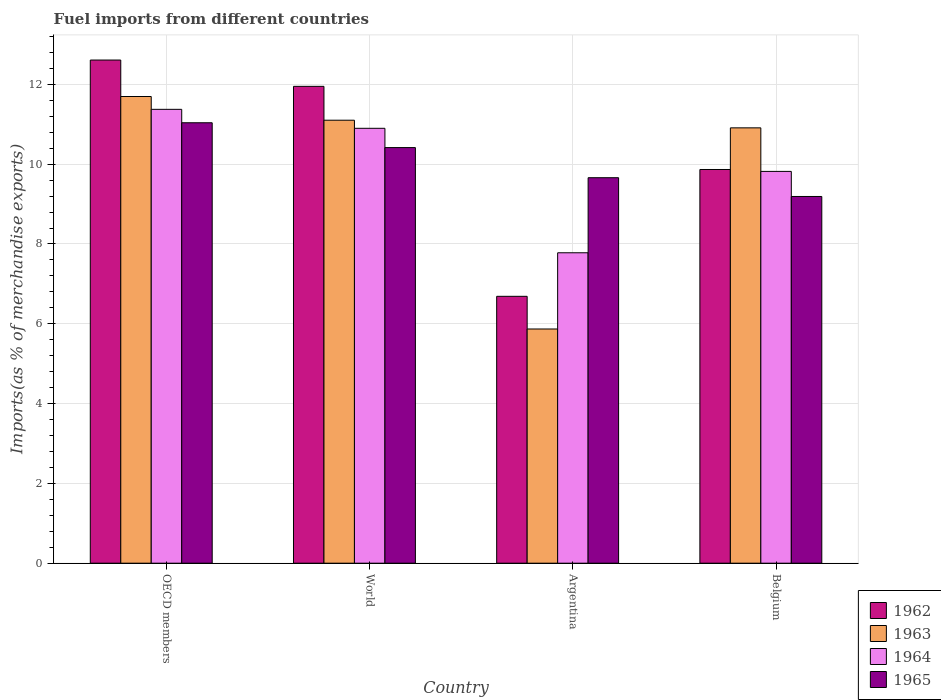How many groups of bars are there?
Your answer should be very brief. 4. Are the number of bars per tick equal to the number of legend labels?
Keep it short and to the point. Yes. Are the number of bars on each tick of the X-axis equal?
Offer a terse response. Yes. How many bars are there on the 4th tick from the right?
Your answer should be very brief. 4. What is the label of the 1st group of bars from the left?
Make the answer very short. OECD members. In how many cases, is the number of bars for a given country not equal to the number of legend labels?
Ensure brevity in your answer.  0. What is the percentage of imports to different countries in 1962 in OECD members?
Your answer should be very brief. 12.61. Across all countries, what is the maximum percentage of imports to different countries in 1963?
Provide a succinct answer. 11.7. Across all countries, what is the minimum percentage of imports to different countries in 1964?
Make the answer very short. 7.78. In which country was the percentage of imports to different countries in 1964 minimum?
Your answer should be very brief. Argentina. What is the total percentage of imports to different countries in 1963 in the graph?
Offer a very short reply. 39.58. What is the difference between the percentage of imports to different countries in 1965 in Argentina and that in World?
Provide a short and direct response. -0.75. What is the difference between the percentage of imports to different countries in 1963 in OECD members and the percentage of imports to different countries in 1965 in Belgium?
Offer a terse response. 2.51. What is the average percentage of imports to different countries in 1963 per country?
Ensure brevity in your answer.  9.89. What is the difference between the percentage of imports to different countries of/in 1965 and percentage of imports to different countries of/in 1964 in Argentina?
Provide a succinct answer. 1.88. In how many countries, is the percentage of imports to different countries in 1963 greater than 8 %?
Keep it short and to the point. 3. What is the ratio of the percentage of imports to different countries in 1964 in Argentina to that in OECD members?
Make the answer very short. 0.68. Is the difference between the percentage of imports to different countries in 1965 in Argentina and World greater than the difference between the percentage of imports to different countries in 1964 in Argentina and World?
Provide a succinct answer. Yes. What is the difference between the highest and the second highest percentage of imports to different countries in 1964?
Offer a very short reply. -1.08. What is the difference between the highest and the lowest percentage of imports to different countries in 1964?
Keep it short and to the point. 3.59. In how many countries, is the percentage of imports to different countries in 1965 greater than the average percentage of imports to different countries in 1965 taken over all countries?
Offer a very short reply. 2. Is the sum of the percentage of imports to different countries in 1963 in OECD members and World greater than the maximum percentage of imports to different countries in 1965 across all countries?
Keep it short and to the point. Yes. What does the 2nd bar from the right in OECD members represents?
Provide a succinct answer. 1964. Are all the bars in the graph horizontal?
Ensure brevity in your answer.  No. What is the difference between two consecutive major ticks on the Y-axis?
Your answer should be very brief. 2. Does the graph contain any zero values?
Your answer should be compact. No. Does the graph contain grids?
Ensure brevity in your answer.  Yes. What is the title of the graph?
Provide a succinct answer. Fuel imports from different countries. What is the label or title of the X-axis?
Your response must be concise. Country. What is the label or title of the Y-axis?
Provide a succinct answer. Imports(as % of merchandise exports). What is the Imports(as % of merchandise exports) of 1962 in OECD members?
Your answer should be compact. 12.61. What is the Imports(as % of merchandise exports) of 1963 in OECD members?
Give a very brief answer. 11.7. What is the Imports(as % of merchandise exports) in 1964 in OECD members?
Keep it short and to the point. 11.37. What is the Imports(as % of merchandise exports) of 1965 in OECD members?
Provide a succinct answer. 11.04. What is the Imports(as % of merchandise exports) of 1962 in World?
Offer a very short reply. 11.95. What is the Imports(as % of merchandise exports) in 1963 in World?
Your answer should be compact. 11.1. What is the Imports(as % of merchandise exports) of 1964 in World?
Your response must be concise. 10.9. What is the Imports(as % of merchandise exports) in 1965 in World?
Your answer should be compact. 10.42. What is the Imports(as % of merchandise exports) of 1962 in Argentina?
Your answer should be compact. 6.69. What is the Imports(as % of merchandise exports) of 1963 in Argentina?
Give a very brief answer. 5.87. What is the Imports(as % of merchandise exports) in 1964 in Argentina?
Give a very brief answer. 7.78. What is the Imports(as % of merchandise exports) of 1965 in Argentina?
Give a very brief answer. 9.66. What is the Imports(as % of merchandise exports) of 1962 in Belgium?
Your answer should be very brief. 9.87. What is the Imports(as % of merchandise exports) of 1963 in Belgium?
Provide a short and direct response. 10.91. What is the Imports(as % of merchandise exports) of 1964 in Belgium?
Make the answer very short. 9.82. What is the Imports(as % of merchandise exports) in 1965 in Belgium?
Your answer should be very brief. 9.19. Across all countries, what is the maximum Imports(as % of merchandise exports) in 1962?
Provide a succinct answer. 12.61. Across all countries, what is the maximum Imports(as % of merchandise exports) in 1963?
Your answer should be very brief. 11.7. Across all countries, what is the maximum Imports(as % of merchandise exports) in 1964?
Provide a short and direct response. 11.37. Across all countries, what is the maximum Imports(as % of merchandise exports) in 1965?
Provide a succinct answer. 11.04. Across all countries, what is the minimum Imports(as % of merchandise exports) in 1962?
Your answer should be compact. 6.69. Across all countries, what is the minimum Imports(as % of merchandise exports) in 1963?
Your answer should be very brief. 5.87. Across all countries, what is the minimum Imports(as % of merchandise exports) of 1964?
Give a very brief answer. 7.78. Across all countries, what is the minimum Imports(as % of merchandise exports) in 1965?
Your answer should be compact. 9.19. What is the total Imports(as % of merchandise exports) in 1962 in the graph?
Your response must be concise. 41.12. What is the total Imports(as % of merchandise exports) in 1963 in the graph?
Provide a short and direct response. 39.58. What is the total Imports(as % of merchandise exports) in 1964 in the graph?
Provide a short and direct response. 39.87. What is the total Imports(as % of merchandise exports) of 1965 in the graph?
Your answer should be very brief. 40.31. What is the difference between the Imports(as % of merchandise exports) of 1962 in OECD members and that in World?
Your answer should be compact. 0.66. What is the difference between the Imports(as % of merchandise exports) of 1963 in OECD members and that in World?
Provide a succinct answer. 0.59. What is the difference between the Imports(as % of merchandise exports) in 1964 in OECD members and that in World?
Your answer should be very brief. 0.48. What is the difference between the Imports(as % of merchandise exports) of 1965 in OECD members and that in World?
Keep it short and to the point. 0.62. What is the difference between the Imports(as % of merchandise exports) of 1962 in OECD members and that in Argentina?
Keep it short and to the point. 5.92. What is the difference between the Imports(as % of merchandise exports) of 1963 in OECD members and that in Argentina?
Provide a short and direct response. 5.83. What is the difference between the Imports(as % of merchandise exports) in 1964 in OECD members and that in Argentina?
Your answer should be very brief. 3.59. What is the difference between the Imports(as % of merchandise exports) of 1965 in OECD members and that in Argentina?
Keep it short and to the point. 1.38. What is the difference between the Imports(as % of merchandise exports) of 1962 in OECD members and that in Belgium?
Provide a succinct answer. 2.74. What is the difference between the Imports(as % of merchandise exports) in 1963 in OECD members and that in Belgium?
Make the answer very short. 0.79. What is the difference between the Imports(as % of merchandise exports) in 1964 in OECD members and that in Belgium?
Your answer should be very brief. 1.56. What is the difference between the Imports(as % of merchandise exports) of 1965 in OECD members and that in Belgium?
Make the answer very short. 1.85. What is the difference between the Imports(as % of merchandise exports) of 1962 in World and that in Argentina?
Ensure brevity in your answer.  5.26. What is the difference between the Imports(as % of merchandise exports) in 1963 in World and that in Argentina?
Offer a very short reply. 5.23. What is the difference between the Imports(as % of merchandise exports) of 1964 in World and that in Argentina?
Your answer should be very brief. 3.12. What is the difference between the Imports(as % of merchandise exports) in 1965 in World and that in Argentina?
Provide a succinct answer. 0.76. What is the difference between the Imports(as % of merchandise exports) of 1962 in World and that in Belgium?
Your answer should be compact. 2.08. What is the difference between the Imports(as % of merchandise exports) of 1963 in World and that in Belgium?
Your response must be concise. 0.19. What is the difference between the Imports(as % of merchandise exports) in 1964 in World and that in Belgium?
Your response must be concise. 1.08. What is the difference between the Imports(as % of merchandise exports) of 1965 in World and that in Belgium?
Ensure brevity in your answer.  1.23. What is the difference between the Imports(as % of merchandise exports) in 1962 in Argentina and that in Belgium?
Keep it short and to the point. -3.18. What is the difference between the Imports(as % of merchandise exports) of 1963 in Argentina and that in Belgium?
Your answer should be very brief. -5.04. What is the difference between the Imports(as % of merchandise exports) in 1964 in Argentina and that in Belgium?
Offer a terse response. -2.04. What is the difference between the Imports(as % of merchandise exports) of 1965 in Argentina and that in Belgium?
Your answer should be very brief. 0.47. What is the difference between the Imports(as % of merchandise exports) of 1962 in OECD members and the Imports(as % of merchandise exports) of 1963 in World?
Offer a very short reply. 1.51. What is the difference between the Imports(as % of merchandise exports) in 1962 in OECD members and the Imports(as % of merchandise exports) in 1964 in World?
Keep it short and to the point. 1.71. What is the difference between the Imports(as % of merchandise exports) in 1962 in OECD members and the Imports(as % of merchandise exports) in 1965 in World?
Your response must be concise. 2.19. What is the difference between the Imports(as % of merchandise exports) in 1963 in OECD members and the Imports(as % of merchandise exports) in 1964 in World?
Provide a short and direct response. 0.8. What is the difference between the Imports(as % of merchandise exports) in 1963 in OECD members and the Imports(as % of merchandise exports) in 1965 in World?
Offer a very short reply. 1.28. What is the difference between the Imports(as % of merchandise exports) in 1964 in OECD members and the Imports(as % of merchandise exports) in 1965 in World?
Your response must be concise. 0.96. What is the difference between the Imports(as % of merchandise exports) in 1962 in OECD members and the Imports(as % of merchandise exports) in 1963 in Argentina?
Provide a short and direct response. 6.74. What is the difference between the Imports(as % of merchandise exports) of 1962 in OECD members and the Imports(as % of merchandise exports) of 1964 in Argentina?
Your answer should be very brief. 4.83. What is the difference between the Imports(as % of merchandise exports) of 1962 in OECD members and the Imports(as % of merchandise exports) of 1965 in Argentina?
Provide a succinct answer. 2.95. What is the difference between the Imports(as % of merchandise exports) of 1963 in OECD members and the Imports(as % of merchandise exports) of 1964 in Argentina?
Your answer should be compact. 3.92. What is the difference between the Imports(as % of merchandise exports) in 1963 in OECD members and the Imports(as % of merchandise exports) in 1965 in Argentina?
Keep it short and to the point. 2.04. What is the difference between the Imports(as % of merchandise exports) of 1964 in OECD members and the Imports(as % of merchandise exports) of 1965 in Argentina?
Your response must be concise. 1.71. What is the difference between the Imports(as % of merchandise exports) of 1962 in OECD members and the Imports(as % of merchandise exports) of 1963 in Belgium?
Provide a short and direct response. 1.7. What is the difference between the Imports(as % of merchandise exports) of 1962 in OECD members and the Imports(as % of merchandise exports) of 1964 in Belgium?
Your answer should be compact. 2.79. What is the difference between the Imports(as % of merchandise exports) of 1962 in OECD members and the Imports(as % of merchandise exports) of 1965 in Belgium?
Ensure brevity in your answer.  3.42. What is the difference between the Imports(as % of merchandise exports) in 1963 in OECD members and the Imports(as % of merchandise exports) in 1964 in Belgium?
Ensure brevity in your answer.  1.88. What is the difference between the Imports(as % of merchandise exports) in 1963 in OECD members and the Imports(as % of merchandise exports) in 1965 in Belgium?
Keep it short and to the point. 2.51. What is the difference between the Imports(as % of merchandise exports) in 1964 in OECD members and the Imports(as % of merchandise exports) in 1965 in Belgium?
Make the answer very short. 2.18. What is the difference between the Imports(as % of merchandise exports) in 1962 in World and the Imports(as % of merchandise exports) in 1963 in Argentina?
Offer a very short reply. 6.08. What is the difference between the Imports(as % of merchandise exports) of 1962 in World and the Imports(as % of merchandise exports) of 1964 in Argentina?
Your answer should be very brief. 4.17. What is the difference between the Imports(as % of merchandise exports) in 1962 in World and the Imports(as % of merchandise exports) in 1965 in Argentina?
Provide a short and direct response. 2.29. What is the difference between the Imports(as % of merchandise exports) in 1963 in World and the Imports(as % of merchandise exports) in 1964 in Argentina?
Your answer should be compact. 3.32. What is the difference between the Imports(as % of merchandise exports) of 1963 in World and the Imports(as % of merchandise exports) of 1965 in Argentina?
Make the answer very short. 1.44. What is the difference between the Imports(as % of merchandise exports) of 1964 in World and the Imports(as % of merchandise exports) of 1965 in Argentina?
Give a very brief answer. 1.24. What is the difference between the Imports(as % of merchandise exports) of 1962 in World and the Imports(as % of merchandise exports) of 1963 in Belgium?
Ensure brevity in your answer.  1.04. What is the difference between the Imports(as % of merchandise exports) of 1962 in World and the Imports(as % of merchandise exports) of 1964 in Belgium?
Your answer should be very brief. 2.13. What is the difference between the Imports(as % of merchandise exports) of 1962 in World and the Imports(as % of merchandise exports) of 1965 in Belgium?
Offer a very short reply. 2.76. What is the difference between the Imports(as % of merchandise exports) in 1963 in World and the Imports(as % of merchandise exports) in 1964 in Belgium?
Offer a terse response. 1.28. What is the difference between the Imports(as % of merchandise exports) in 1963 in World and the Imports(as % of merchandise exports) in 1965 in Belgium?
Give a very brief answer. 1.91. What is the difference between the Imports(as % of merchandise exports) of 1964 in World and the Imports(as % of merchandise exports) of 1965 in Belgium?
Offer a very short reply. 1.71. What is the difference between the Imports(as % of merchandise exports) in 1962 in Argentina and the Imports(as % of merchandise exports) in 1963 in Belgium?
Your answer should be compact. -4.22. What is the difference between the Imports(as % of merchandise exports) in 1962 in Argentina and the Imports(as % of merchandise exports) in 1964 in Belgium?
Offer a terse response. -3.13. What is the difference between the Imports(as % of merchandise exports) of 1962 in Argentina and the Imports(as % of merchandise exports) of 1965 in Belgium?
Provide a succinct answer. -2.5. What is the difference between the Imports(as % of merchandise exports) of 1963 in Argentina and the Imports(as % of merchandise exports) of 1964 in Belgium?
Ensure brevity in your answer.  -3.95. What is the difference between the Imports(as % of merchandise exports) of 1963 in Argentina and the Imports(as % of merchandise exports) of 1965 in Belgium?
Make the answer very short. -3.32. What is the difference between the Imports(as % of merchandise exports) in 1964 in Argentina and the Imports(as % of merchandise exports) in 1965 in Belgium?
Provide a short and direct response. -1.41. What is the average Imports(as % of merchandise exports) of 1962 per country?
Provide a succinct answer. 10.28. What is the average Imports(as % of merchandise exports) of 1963 per country?
Ensure brevity in your answer.  9.89. What is the average Imports(as % of merchandise exports) in 1964 per country?
Keep it short and to the point. 9.97. What is the average Imports(as % of merchandise exports) in 1965 per country?
Provide a succinct answer. 10.08. What is the difference between the Imports(as % of merchandise exports) of 1962 and Imports(as % of merchandise exports) of 1963 in OECD members?
Provide a short and direct response. 0.91. What is the difference between the Imports(as % of merchandise exports) in 1962 and Imports(as % of merchandise exports) in 1964 in OECD members?
Offer a terse response. 1.24. What is the difference between the Imports(as % of merchandise exports) of 1962 and Imports(as % of merchandise exports) of 1965 in OECD members?
Offer a terse response. 1.57. What is the difference between the Imports(as % of merchandise exports) in 1963 and Imports(as % of merchandise exports) in 1964 in OECD members?
Ensure brevity in your answer.  0.32. What is the difference between the Imports(as % of merchandise exports) of 1963 and Imports(as % of merchandise exports) of 1965 in OECD members?
Your answer should be very brief. 0.66. What is the difference between the Imports(as % of merchandise exports) in 1964 and Imports(as % of merchandise exports) in 1965 in OECD members?
Ensure brevity in your answer.  0.34. What is the difference between the Imports(as % of merchandise exports) in 1962 and Imports(as % of merchandise exports) in 1963 in World?
Ensure brevity in your answer.  0.85. What is the difference between the Imports(as % of merchandise exports) of 1962 and Imports(as % of merchandise exports) of 1964 in World?
Your answer should be very brief. 1.05. What is the difference between the Imports(as % of merchandise exports) in 1962 and Imports(as % of merchandise exports) in 1965 in World?
Your answer should be compact. 1.53. What is the difference between the Imports(as % of merchandise exports) in 1963 and Imports(as % of merchandise exports) in 1964 in World?
Ensure brevity in your answer.  0.2. What is the difference between the Imports(as % of merchandise exports) in 1963 and Imports(as % of merchandise exports) in 1965 in World?
Offer a terse response. 0.69. What is the difference between the Imports(as % of merchandise exports) in 1964 and Imports(as % of merchandise exports) in 1965 in World?
Your response must be concise. 0.48. What is the difference between the Imports(as % of merchandise exports) of 1962 and Imports(as % of merchandise exports) of 1963 in Argentina?
Offer a terse response. 0.82. What is the difference between the Imports(as % of merchandise exports) in 1962 and Imports(as % of merchandise exports) in 1964 in Argentina?
Your answer should be very brief. -1.09. What is the difference between the Imports(as % of merchandise exports) of 1962 and Imports(as % of merchandise exports) of 1965 in Argentina?
Your answer should be very brief. -2.97. What is the difference between the Imports(as % of merchandise exports) in 1963 and Imports(as % of merchandise exports) in 1964 in Argentina?
Your answer should be compact. -1.91. What is the difference between the Imports(as % of merchandise exports) in 1963 and Imports(as % of merchandise exports) in 1965 in Argentina?
Your response must be concise. -3.79. What is the difference between the Imports(as % of merchandise exports) of 1964 and Imports(as % of merchandise exports) of 1965 in Argentina?
Provide a succinct answer. -1.88. What is the difference between the Imports(as % of merchandise exports) in 1962 and Imports(as % of merchandise exports) in 1963 in Belgium?
Offer a terse response. -1.04. What is the difference between the Imports(as % of merchandise exports) of 1962 and Imports(as % of merchandise exports) of 1964 in Belgium?
Provide a short and direct response. 0.05. What is the difference between the Imports(as % of merchandise exports) of 1962 and Imports(as % of merchandise exports) of 1965 in Belgium?
Provide a short and direct response. 0.68. What is the difference between the Imports(as % of merchandise exports) of 1963 and Imports(as % of merchandise exports) of 1964 in Belgium?
Offer a very short reply. 1.09. What is the difference between the Imports(as % of merchandise exports) in 1963 and Imports(as % of merchandise exports) in 1965 in Belgium?
Your response must be concise. 1.72. What is the difference between the Imports(as % of merchandise exports) in 1964 and Imports(as % of merchandise exports) in 1965 in Belgium?
Ensure brevity in your answer.  0.63. What is the ratio of the Imports(as % of merchandise exports) in 1962 in OECD members to that in World?
Your answer should be very brief. 1.06. What is the ratio of the Imports(as % of merchandise exports) in 1963 in OECD members to that in World?
Provide a succinct answer. 1.05. What is the ratio of the Imports(as % of merchandise exports) of 1964 in OECD members to that in World?
Your answer should be very brief. 1.04. What is the ratio of the Imports(as % of merchandise exports) of 1965 in OECD members to that in World?
Offer a terse response. 1.06. What is the ratio of the Imports(as % of merchandise exports) in 1962 in OECD members to that in Argentina?
Keep it short and to the point. 1.89. What is the ratio of the Imports(as % of merchandise exports) in 1963 in OECD members to that in Argentina?
Keep it short and to the point. 1.99. What is the ratio of the Imports(as % of merchandise exports) of 1964 in OECD members to that in Argentina?
Provide a short and direct response. 1.46. What is the ratio of the Imports(as % of merchandise exports) of 1965 in OECD members to that in Argentina?
Make the answer very short. 1.14. What is the ratio of the Imports(as % of merchandise exports) in 1962 in OECD members to that in Belgium?
Offer a terse response. 1.28. What is the ratio of the Imports(as % of merchandise exports) in 1963 in OECD members to that in Belgium?
Offer a very short reply. 1.07. What is the ratio of the Imports(as % of merchandise exports) in 1964 in OECD members to that in Belgium?
Your answer should be compact. 1.16. What is the ratio of the Imports(as % of merchandise exports) in 1965 in OECD members to that in Belgium?
Provide a succinct answer. 1.2. What is the ratio of the Imports(as % of merchandise exports) of 1962 in World to that in Argentina?
Your response must be concise. 1.79. What is the ratio of the Imports(as % of merchandise exports) of 1963 in World to that in Argentina?
Provide a succinct answer. 1.89. What is the ratio of the Imports(as % of merchandise exports) in 1964 in World to that in Argentina?
Your response must be concise. 1.4. What is the ratio of the Imports(as % of merchandise exports) in 1965 in World to that in Argentina?
Your answer should be compact. 1.08. What is the ratio of the Imports(as % of merchandise exports) of 1962 in World to that in Belgium?
Keep it short and to the point. 1.21. What is the ratio of the Imports(as % of merchandise exports) in 1963 in World to that in Belgium?
Provide a short and direct response. 1.02. What is the ratio of the Imports(as % of merchandise exports) of 1964 in World to that in Belgium?
Offer a terse response. 1.11. What is the ratio of the Imports(as % of merchandise exports) in 1965 in World to that in Belgium?
Give a very brief answer. 1.13. What is the ratio of the Imports(as % of merchandise exports) of 1962 in Argentina to that in Belgium?
Ensure brevity in your answer.  0.68. What is the ratio of the Imports(as % of merchandise exports) in 1963 in Argentina to that in Belgium?
Offer a terse response. 0.54. What is the ratio of the Imports(as % of merchandise exports) of 1964 in Argentina to that in Belgium?
Ensure brevity in your answer.  0.79. What is the ratio of the Imports(as % of merchandise exports) of 1965 in Argentina to that in Belgium?
Provide a short and direct response. 1.05. What is the difference between the highest and the second highest Imports(as % of merchandise exports) in 1962?
Your response must be concise. 0.66. What is the difference between the highest and the second highest Imports(as % of merchandise exports) of 1963?
Keep it short and to the point. 0.59. What is the difference between the highest and the second highest Imports(as % of merchandise exports) of 1964?
Your response must be concise. 0.48. What is the difference between the highest and the second highest Imports(as % of merchandise exports) of 1965?
Offer a very short reply. 0.62. What is the difference between the highest and the lowest Imports(as % of merchandise exports) in 1962?
Your answer should be very brief. 5.92. What is the difference between the highest and the lowest Imports(as % of merchandise exports) in 1963?
Provide a succinct answer. 5.83. What is the difference between the highest and the lowest Imports(as % of merchandise exports) in 1964?
Your answer should be compact. 3.59. What is the difference between the highest and the lowest Imports(as % of merchandise exports) in 1965?
Offer a terse response. 1.85. 